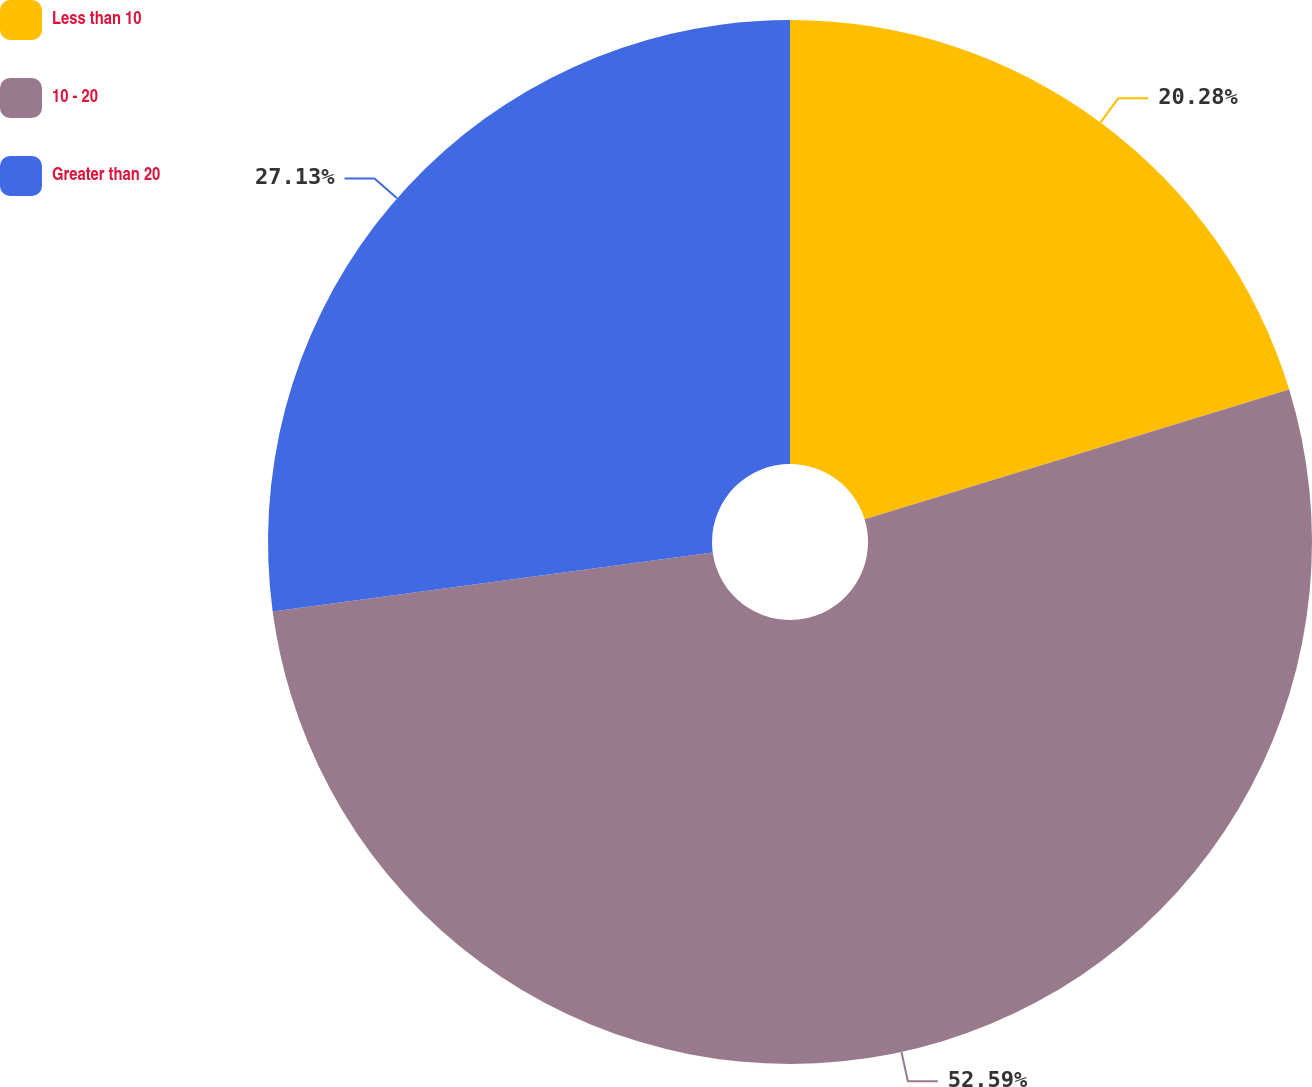<chart> <loc_0><loc_0><loc_500><loc_500><pie_chart><fcel>Less than 10<fcel>10 - 20<fcel>Greater than 20<nl><fcel>20.28%<fcel>52.6%<fcel>27.13%<nl></chart> 